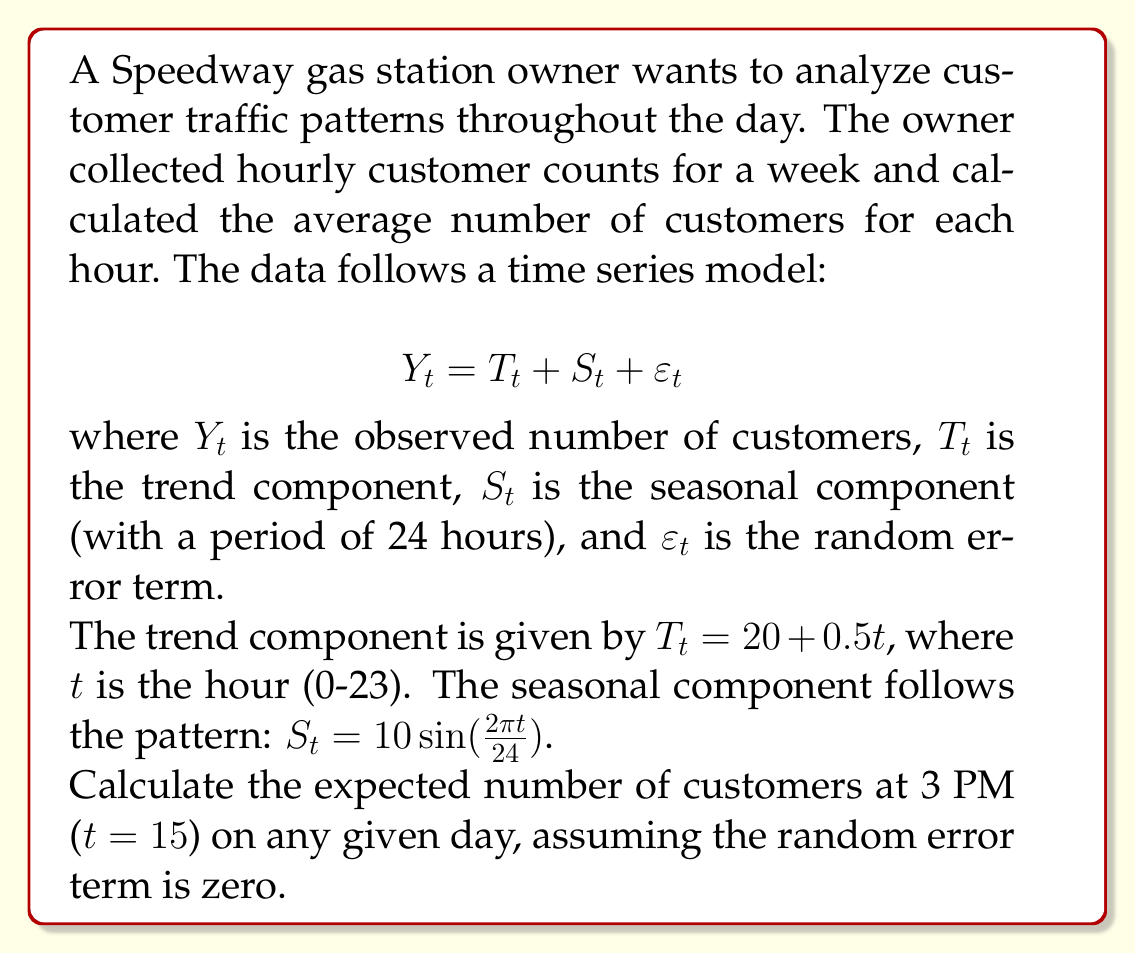What is the answer to this math problem? To solve this problem, we need to use the given time series model and calculate each component:

1. Trend component ($T_t$):
   $$T_t = 20 + 0.5t$$
   At t = 15 (3 PM), we have:
   $$T_{15} = 20 + 0.5(15) = 20 + 7.5 = 27.5$$

2. Seasonal component ($S_t$):
   $$S_t = 10\sin(\frac{2\pi t}{24})$$
   At t = 15, we have:
   $$S_{15} = 10\sin(\frac{2\pi(15)}{24}) = 10\sin(\frac{5\pi}{8}) \approx 9.239$$

3. Random error term ($\varepsilon_t$):
   Given that the random error term is assumed to be zero, $\varepsilon_{15} = 0$.

Now, we can combine these components using the time series model:

$$Y_t = T_t + S_t + \varepsilon_t$$
$$Y_{15} = T_{15} + S_{15} + \varepsilon_{15}$$
$$Y_{15} = 27.5 + 9.239 + 0 = 36.739$$

Therefore, the expected number of customers at 3 PM on any given day is approximately 36.739.
Answer: 36.739 customers (rounded to three decimal places) 